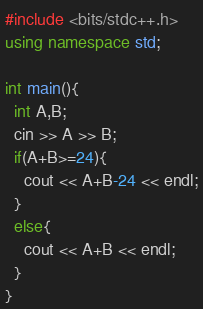Convert code to text. <code><loc_0><loc_0><loc_500><loc_500><_C++_>#include <bits/stdc++.h>
using namespace std;

int main(){
  int A,B;
  cin >> A >> B;
  if(A+B>=24){
    cout << A+B-24 << endl;
  }
  else{
    cout << A+B << endl;
  }
}</code> 